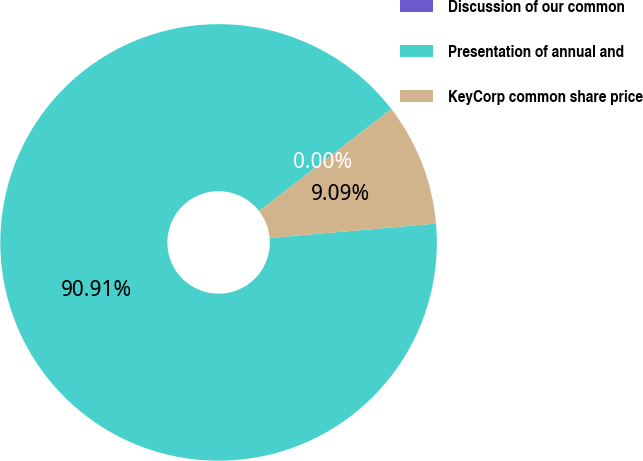<chart> <loc_0><loc_0><loc_500><loc_500><pie_chart><fcel>Discussion of our common<fcel>Presentation of annual and<fcel>KeyCorp common share price<nl><fcel>0.0%<fcel>90.91%<fcel>9.09%<nl></chart> 